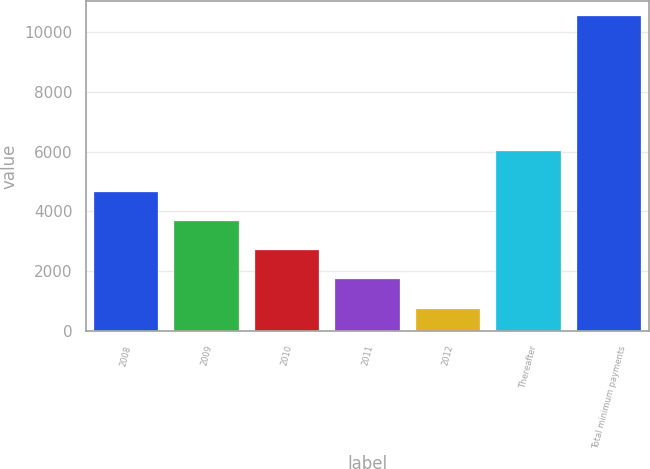Convert chart. <chart><loc_0><loc_0><loc_500><loc_500><bar_chart><fcel>2008<fcel>2009<fcel>2010<fcel>2011<fcel>2012<fcel>Thereafter<fcel>Total minimum payments<nl><fcel>4659.9<fcel>3684.25<fcel>2708.6<fcel>1732.95<fcel>757.3<fcel>6008.6<fcel>10513.8<nl></chart> 